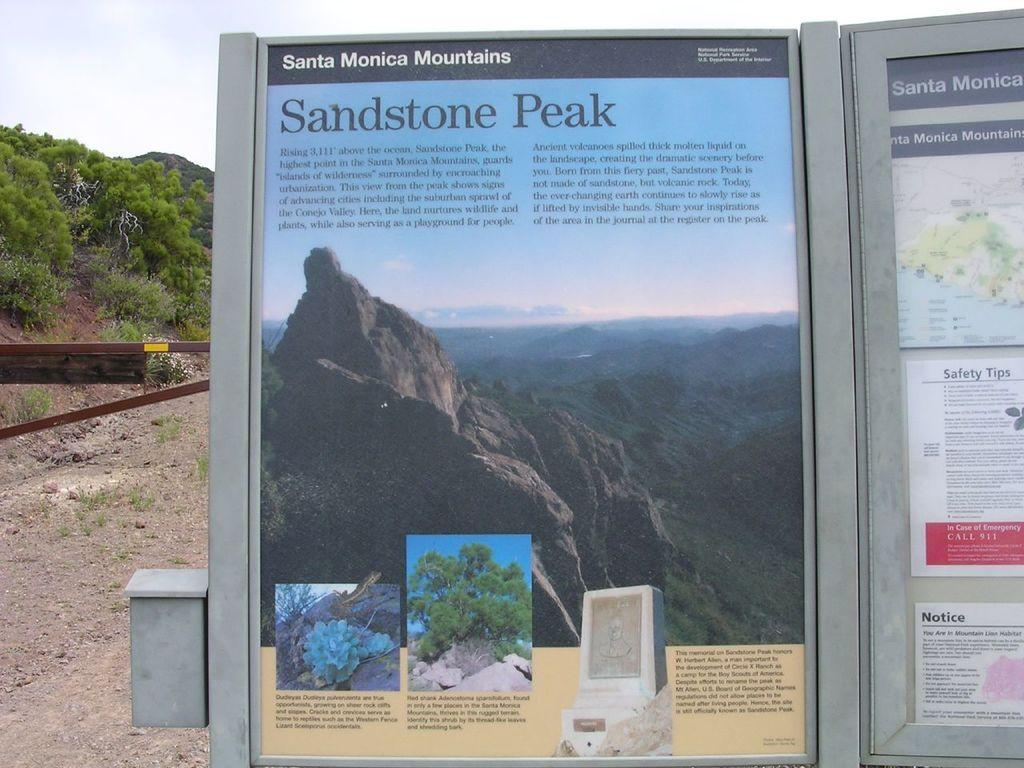What is the main object in the foreground of the image? There is an advertising board in the image. Where is the advertising board located in relation to the image? The advertising board is in the front of the image. What type of surface can be seen in the image? There is a ground visible in the image. What type of vegetation is present in the image? There are trees in the image. How many passengers are visible on the advertising board in the image? There are no passengers present on the advertising board in the image. What type of cord is used to hang the advertising board in the image? There is no cord visible in the image, and the method of hanging the advertising board is not mentioned. 